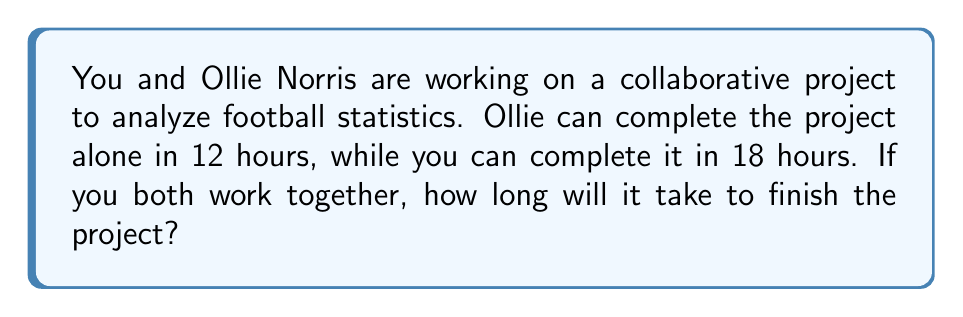What is the answer to this math problem? Let's approach this step-by-step:

1) First, we need to determine the rate at which each person works:
   - Ollie's rate: $\frac{1}{12}$ of the project per hour
   - Your rate: $\frac{1}{18}$ of the project per hour

2) When working together, the combined rate will be the sum of individual rates:
   $$ \text{Combined rate} = \frac{1}{12} + \frac{1}{18} $$

3) To add these fractions, we need a common denominator:
   $$ \frac{1}{12} + \frac{1}{18} = \frac{3}{36} + \frac{2}{36} = \frac{5}{36} \text{ of the project per hour} $$

4) Now, we want to find how long it takes to complete the whole project at this combined rate:
   $$ \text{Time} \times \text{Rate} = \text{Whole project} $$
   $$ \text{Time} \times \frac{5}{36} = 1 $$

5) Solving for Time:
   $$ \text{Time} = \frac{1}{\frac{5}{36}} = \frac{36}{5} = 7.2 \text{ hours} $$

Therefore, working together, you and Ollie will complete the project in 7.2 hours.
Answer: 7.2 hours 